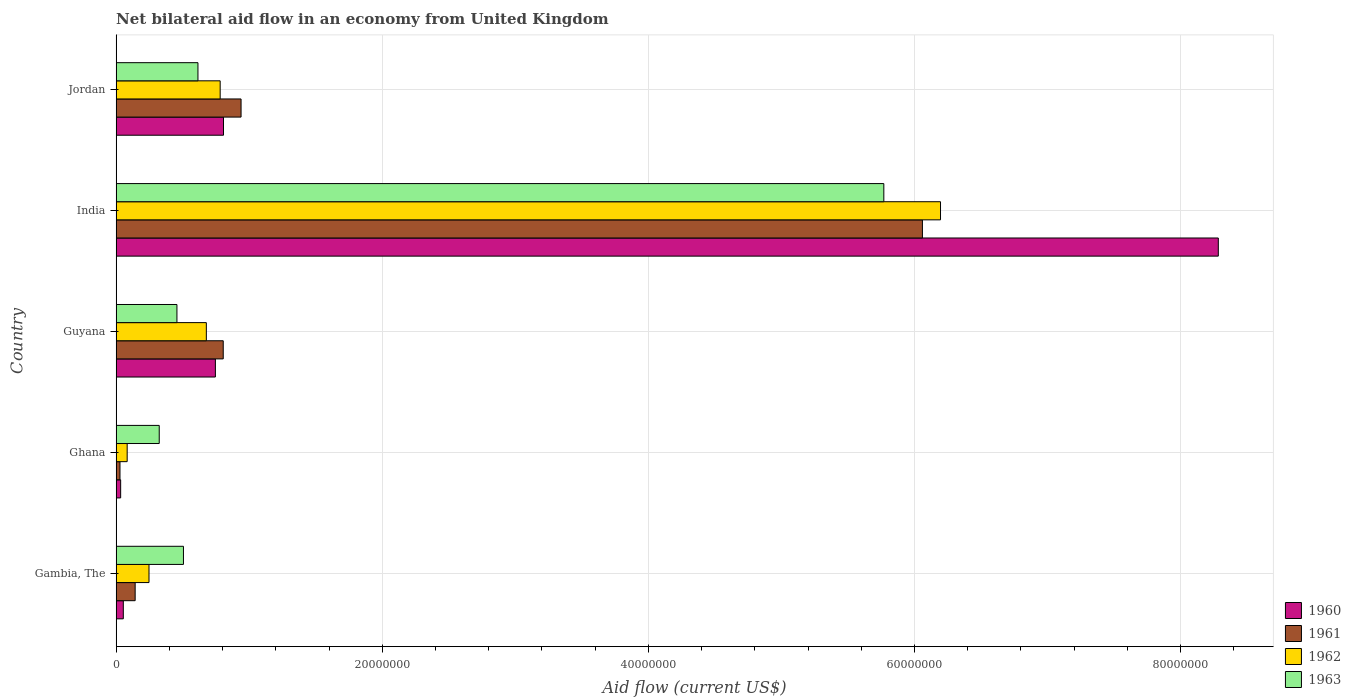How many different coloured bars are there?
Ensure brevity in your answer.  4. Are the number of bars per tick equal to the number of legend labels?
Give a very brief answer. Yes. Are the number of bars on each tick of the Y-axis equal?
Your response must be concise. Yes. How many bars are there on the 3rd tick from the top?
Give a very brief answer. 4. What is the label of the 1st group of bars from the top?
Your answer should be compact. Jordan. In how many cases, is the number of bars for a given country not equal to the number of legend labels?
Provide a succinct answer. 0. What is the net bilateral aid flow in 1963 in India?
Provide a short and direct response. 5.77e+07. Across all countries, what is the maximum net bilateral aid flow in 1962?
Ensure brevity in your answer.  6.20e+07. Across all countries, what is the minimum net bilateral aid flow in 1961?
Provide a succinct answer. 2.90e+05. In which country was the net bilateral aid flow in 1963 maximum?
Ensure brevity in your answer.  India. What is the total net bilateral aid flow in 1960 in the graph?
Offer a very short reply. 9.92e+07. What is the difference between the net bilateral aid flow in 1962 in Ghana and that in Guyana?
Give a very brief answer. -5.95e+06. What is the difference between the net bilateral aid flow in 1962 in Jordan and the net bilateral aid flow in 1960 in Gambia, The?
Give a very brief answer. 7.28e+06. What is the average net bilateral aid flow in 1961 per country?
Keep it short and to the point. 1.60e+07. What is the difference between the net bilateral aid flow in 1960 and net bilateral aid flow in 1961 in Guyana?
Offer a terse response. -5.90e+05. In how many countries, is the net bilateral aid flow in 1963 greater than 68000000 US$?
Your answer should be very brief. 0. What is the ratio of the net bilateral aid flow in 1961 in Gambia, The to that in Ghana?
Give a very brief answer. 4.93. Is the net bilateral aid flow in 1963 in Gambia, The less than that in Jordan?
Ensure brevity in your answer.  Yes. Is the difference between the net bilateral aid flow in 1960 in Ghana and Guyana greater than the difference between the net bilateral aid flow in 1961 in Ghana and Guyana?
Give a very brief answer. Yes. What is the difference between the highest and the second highest net bilateral aid flow in 1961?
Your answer should be very brief. 5.12e+07. What is the difference between the highest and the lowest net bilateral aid flow in 1962?
Ensure brevity in your answer.  6.11e+07. Is the sum of the net bilateral aid flow in 1961 in Gambia, The and Guyana greater than the maximum net bilateral aid flow in 1963 across all countries?
Ensure brevity in your answer.  No. Is it the case that in every country, the sum of the net bilateral aid flow in 1960 and net bilateral aid flow in 1962 is greater than the sum of net bilateral aid flow in 1961 and net bilateral aid flow in 1963?
Give a very brief answer. No. What does the 3rd bar from the top in Guyana represents?
Your answer should be compact. 1961. What does the 2nd bar from the bottom in Guyana represents?
Your response must be concise. 1961. Is it the case that in every country, the sum of the net bilateral aid flow in 1960 and net bilateral aid flow in 1963 is greater than the net bilateral aid flow in 1961?
Your answer should be very brief. Yes. How many countries are there in the graph?
Ensure brevity in your answer.  5. Does the graph contain any zero values?
Your answer should be compact. No. What is the title of the graph?
Your response must be concise. Net bilateral aid flow in an economy from United Kingdom. What is the label or title of the X-axis?
Keep it short and to the point. Aid flow (current US$). What is the label or title of the Y-axis?
Ensure brevity in your answer.  Country. What is the Aid flow (current US$) in 1960 in Gambia, The?
Make the answer very short. 5.40e+05. What is the Aid flow (current US$) in 1961 in Gambia, The?
Offer a very short reply. 1.43e+06. What is the Aid flow (current US$) of 1962 in Gambia, The?
Ensure brevity in your answer.  2.47e+06. What is the Aid flow (current US$) in 1963 in Gambia, The?
Ensure brevity in your answer.  5.06e+06. What is the Aid flow (current US$) of 1960 in Ghana?
Your answer should be very brief. 3.40e+05. What is the Aid flow (current US$) in 1962 in Ghana?
Offer a terse response. 8.30e+05. What is the Aid flow (current US$) of 1963 in Ghana?
Offer a terse response. 3.24e+06. What is the Aid flow (current US$) of 1960 in Guyana?
Provide a short and direct response. 7.46e+06. What is the Aid flow (current US$) in 1961 in Guyana?
Provide a short and direct response. 8.05e+06. What is the Aid flow (current US$) in 1962 in Guyana?
Your response must be concise. 6.78e+06. What is the Aid flow (current US$) of 1963 in Guyana?
Your response must be concise. 4.57e+06. What is the Aid flow (current US$) of 1960 in India?
Your response must be concise. 8.28e+07. What is the Aid flow (current US$) of 1961 in India?
Give a very brief answer. 6.06e+07. What is the Aid flow (current US$) of 1962 in India?
Keep it short and to the point. 6.20e+07. What is the Aid flow (current US$) of 1963 in India?
Give a very brief answer. 5.77e+07. What is the Aid flow (current US$) in 1960 in Jordan?
Your answer should be compact. 8.07e+06. What is the Aid flow (current US$) of 1961 in Jordan?
Your answer should be compact. 9.39e+06. What is the Aid flow (current US$) in 1962 in Jordan?
Your answer should be compact. 7.82e+06. What is the Aid flow (current US$) of 1963 in Jordan?
Offer a very short reply. 6.15e+06. Across all countries, what is the maximum Aid flow (current US$) in 1960?
Give a very brief answer. 8.28e+07. Across all countries, what is the maximum Aid flow (current US$) of 1961?
Keep it short and to the point. 6.06e+07. Across all countries, what is the maximum Aid flow (current US$) in 1962?
Give a very brief answer. 6.20e+07. Across all countries, what is the maximum Aid flow (current US$) of 1963?
Make the answer very short. 5.77e+07. Across all countries, what is the minimum Aid flow (current US$) in 1960?
Give a very brief answer. 3.40e+05. Across all countries, what is the minimum Aid flow (current US$) of 1962?
Offer a terse response. 8.30e+05. Across all countries, what is the minimum Aid flow (current US$) in 1963?
Offer a terse response. 3.24e+06. What is the total Aid flow (current US$) in 1960 in the graph?
Offer a very short reply. 9.92e+07. What is the total Aid flow (current US$) of 1961 in the graph?
Provide a succinct answer. 7.98e+07. What is the total Aid flow (current US$) of 1962 in the graph?
Give a very brief answer. 7.99e+07. What is the total Aid flow (current US$) in 1963 in the graph?
Provide a succinct answer. 7.67e+07. What is the difference between the Aid flow (current US$) in 1960 in Gambia, The and that in Ghana?
Give a very brief answer. 2.00e+05. What is the difference between the Aid flow (current US$) in 1961 in Gambia, The and that in Ghana?
Offer a terse response. 1.14e+06. What is the difference between the Aid flow (current US$) of 1962 in Gambia, The and that in Ghana?
Offer a very short reply. 1.64e+06. What is the difference between the Aid flow (current US$) in 1963 in Gambia, The and that in Ghana?
Keep it short and to the point. 1.82e+06. What is the difference between the Aid flow (current US$) in 1960 in Gambia, The and that in Guyana?
Provide a short and direct response. -6.92e+06. What is the difference between the Aid flow (current US$) of 1961 in Gambia, The and that in Guyana?
Provide a succinct answer. -6.62e+06. What is the difference between the Aid flow (current US$) in 1962 in Gambia, The and that in Guyana?
Keep it short and to the point. -4.31e+06. What is the difference between the Aid flow (current US$) in 1963 in Gambia, The and that in Guyana?
Provide a succinct answer. 4.90e+05. What is the difference between the Aid flow (current US$) in 1960 in Gambia, The and that in India?
Give a very brief answer. -8.23e+07. What is the difference between the Aid flow (current US$) in 1961 in Gambia, The and that in India?
Make the answer very short. -5.92e+07. What is the difference between the Aid flow (current US$) in 1962 in Gambia, The and that in India?
Your answer should be compact. -5.95e+07. What is the difference between the Aid flow (current US$) of 1963 in Gambia, The and that in India?
Your answer should be compact. -5.26e+07. What is the difference between the Aid flow (current US$) of 1960 in Gambia, The and that in Jordan?
Ensure brevity in your answer.  -7.53e+06. What is the difference between the Aid flow (current US$) in 1961 in Gambia, The and that in Jordan?
Provide a succinct answer. -7.96e+06. What is the difference between the Aid flow (current US$) of 1962 in Gambia, The and that in Jordan?
Keep it short and to the point. -5.35e+06. What is the difference between the Aid flow (current US$) of 1963 in Gambia, The and that in Jordan?
Provide a succinct answer. -1.09e+06. What is the difference between the Aid flow (current US$) of 1960 in Ghana and that in Guyana?
Provide a succinct answer. -7.12e+06. What is the difference between the Aid flow (current US$) of 1961 in Ghana and that in Guyana?
Provide a succinct answer. -7.76e+06. What is the difference between the Aid flow (current US$) in 1962 in Ghana and that in Guyana?
Offer a terse response. -5.95e+06. What is the difference between the Aid flow (current US$) in 1963 in Ghana and that in Guyana?
Your answer should be very brief. -1.33e+06. What is the difference between the Aid flow (current US$) of 1960 in Ghana and that in India?
Ensure brevity in your answer.  -8.25e+07. What is the difference between the Aid flow (current US$) in 1961 in Ghana and that in India?
Provide a short and direct response. -6.03e+07. What is the difference between the Aid flow (current US$) in 1962 in Ghana and that in India?
Your response must be concise. -6.11e+07. What is the difference between the Aid flow (current US$) in 1963 in Ghana and that in India?
Your answer should be compact. -5.45e+07. What is the difference between the Aid flow (current US$) of 1960 in Ghana and that in Jordan?
Your answer should be very brief. -7.73e+06. What is the difference between the Aid flow (current US$) in 1961 in Ghana and that in Jordan?
Give a very brief answer. -9.10e+06. What is the difference between the Aid flow (current US$) of 1962 in Ghana and that in Jordan?
Keep it short and to the point. -6.99e+06. What is the difference between the Aid flow (current US$) of 1963 in Ghana and that in Jordan?
Ensure brevity in your answer.  -2.91e+06. What is the difference between the Aid flow (current US$) in 1960 in Guyana and that in India?
Offer a very short reply. -7.54e+07. What is the difference between the Aid flow (current US$) in 1961 in Guyana and that in India?
Ensure brevity in your answer.  -5.26e+07. What is the difference between the Aid flow (current US$) in 1962 in Guyana and that in India?
Make the answer very short. -5.52e+07. What is the difference between the Aid flow (current US$) in 1963 in Guyana and that in India?
Give a very brief answer. -5.31e+07. What is the difference between the Aid flow (current US$) of 1960 in Guyana and that in Jordan?
Your answer should be compact. -6.10e+05. What is the difference between the Aid flow (current US$) of 1961 in Guyana and that in Jordan?
Your answer should be compact. -1.34e+06. What is the difference between the Aid flow (current US$) of 1962 in Guyana and that in Jordan?
Provide a short and direct response. -1.04e+06. What is the difference between the Aid flow (current US$) in 1963 in Guyana and that in Jordan?
Your answer should be very brief. -1.58e+06. What is the difference between the Aid flow (current US$) in 1960 in India and that in Jordan?
Give a very brief answer. 7.48e+07. What is the difference between the Aid flow (current US$) of 1961 in India and that in Jordan?
Give a very brief answer. 5.12e+07. What is the difference between the Aid flow (current US$) in 1962 in India and that in Jordan?
Give a very brief answer. 5.41e+07. What is the difference between the Aid flow (current US$) in 1963 in India and that in Jordan?
Your answer should be very brief. 5.16e+07. What is the difference between the Aid flow (current US$) of 1960 in Gambia, The and the Aid flow (current US$) of 1961 in Ghana?
Offer a terse response. 2.50e+05. What is the difference between the Aid flow (current US$) in 1960 in Gambia, The and the Aid flow (current US$) in 1963 in Ghana?
Provide a short and direct response. -2.70e+06. What is the difference between the Aid flow (current US$) in 1961 in Gambia, The and the Aid flow (current US$) in 1962 in Ghana?
Keep it short and to the point. 6.00e+05. What is the difference between the Aid flow (current US$) in 1961 in Gambia, The and the Aid flow (current US$) in 1963 in Ghana?
Your answer should be very brief. -1.81e+06. What is the difference between the Aid flow (current US$) of 1962 in Gambia, The and the Aid flow (current US$) of 1963 in Ghana?
Make the answer very short. -7.70e+05. What is the difference between the Aid flow (current US$) of 1960 in Gambia, The and the Aid flow (current US$) of 1961 in Guyana?
Provide a short and direct response. -7.51e+06. What is the difference between the Aid flow (current US$) of 1960 in Gambia, The and the Aid flow (current US$) of 1962 in Guyana?
Your answer should be very brief. -6.24e+06. What is the difference between the Aid flow (current US$) in 1960 in Gambia, The and the Aid flow (current US$) in 1963 in Guyana?
Give a very brief answer. -4.03e+06. What is the difference between the Aid flow (current US$) in 1961 in Gambia, The and the Aid flow (current US$) in 1962 in Guyana?
Give a very brief answer. -5.35e+06. What is the difference between the Aid flow (current US$) of 1961 in Gambia, The and the Aid flow (current US$) of 1963 in Guyana?
Give a very brief answer. -3.14e+06. What is the difference between the Aid flow (current US$) in 1962 in Gambia, The and the Aid flow (current US$) in 1963 in Guyana?
Your answer should be compact. -2.10e+06. What is the difference between the Aid flow (current US$) in 1960 in Gambia, The and the Aid flow (current US$) in 1961 in India?
Make the answer very short. -6.01e+07. What is the difference between the Aid flow (current US$) in 1960 in Gambia, The and the Aid flow (current US$) in 1962 in India?
Your answer should be very brief. -6.14e+07. What is the difference between the Aid flow (current US$) in 1960 in Gambia, The and the Aid flow (current US$) in 1963 in India?
Your response must be concise. -5.72e+07. What is the difference between the Aid flow (current US$) in 1961 in Gambia, The and the Aid flow (current US$) in 1962 in India?
Offer a terse response. -6.05e+07. What is the difference between the Aid flow (current US$) of 1961 in Gambia, The and the Aid flow (current US$) of 1963 in India?
Provide a succinct answer. -5.63e+07. What is the difference between the Aid flow (current US$) in 1962 in Gambia, The and the Aid flow (current US$) in 1963 in India?
Ensure brevity in your answer.  -5.52e+07. What is the difference between the Aid flow (current US$) in 1960 in Gambia, The and the Aid flow (current US$) in 1961 in Jordan?
Ensure brevity in your answer.  -8.85e+06. What is the difference between the Aid flow (current US$) of 1960 in Gambia, The and the Aid flow (current US$) of 1962 in Jordan?
Make the answer very short. -7.28e+06. What is the difference between the Aid flow (current US$) in 1960 in Gambia, The and the Aid flow (current US$) in 1963 in Jordan?
Offer a very short reply. -5.61e+06. What is the difference between the Aid flow (current US$) of 1961 in Gambia, The and the Aid flow (current US$) of 1962 in Jordan?
Offer a terse response. -6.39e+06. What is the difference between the Aid flow (current US$) of 1961 in Gambia, The and the Aid flow (current US$) of 1963 in Jordan?
Make the answer very short. -4.72e+06. What is the difference between the Aid flow (current US$) in 1962 in Gambia, The and the Aid flow (current US$) in 1963 in Jordan?
Your response must be concise. -3.68e+06. What is the difference between the Aid flow (current US$) in 1960 in Ghana and the Aid flow (current US$) in 1961 in Guyana?
Offer a very short reply. -7.71e+06. What is the difference between the Aid flow (current US$) in 1960 in Ghana and the Aid flow (current US$) in 1962 in Guyana?
Make the answer very short. -6.44e+06. What is the difference between the Aid flow (current US$) in 1960 in Ghana and the Aid flow (current US$) in 1963 in Guyana?
Ensure brevity in your answer.  -4.23e+06. What is the difference between the Aid flow (current US$) in 1961 in Ghana and the Aid flow (current US$) in 1962 in Guyana?
Provide a succinct answer. -6.49e+06. What is the difference between the Aid flow (current US$) in 1961 in Ghana and the Aid flow (current US$) in 1963 in Guyana?
Give a very brief answer. -4.28e+06. What is the difference between the Aid flow (current US$) in 1962 in Ghana and the Aid flow (current US$) in 1963 in Guyana?
Keep it short and to the point. -3.74e+06. What is the difference between the Aid flow (current US$) in 1960 in Ghana and the Aid flow (current US$) in 1961 in India?
Your answer should be very brief. -6.03e+07. What is the difference between the Aid flow (current US$) in 1960 in Ghana and the Aid flow (current US$) in 1962 in India?
Make the answer very short. -6.16e+07. What is the difference between the Aid flow (current US$) of 1960 in Ghana and the Aid flow (current US$) of 1963 in India?
Make the answer very short. -5.74e+07. What is the difference between the Aid flow (current US$) of 1961 in Ghana and the Aid flow (current US$) of 1962 in India?
Your response must be concise. -6.17e+07. What is the difference between the Aid flow (current US$) of 1961 in Ghana and the Aid flow (current US$) of 1963 in India?
Your answer should be compact. -5.74e+07. What is the difference between the Aid flow (current US$) of 1962 in Ghana and the Aid flow (current US$) of 1963 in India?
Your answer should be compact. -5.69e+07. What is the difference between the Aid flow (current US$) in 1960 in Ghana and the Aid flow (current US$) in 1961 in Jordan?
Provide a short and direct response. -9.05e+06. What is the difference between the Aid flow (current US$) in 1960 in Ghana and the Aid flow (current US$) in 1962 in Jordan?
Offer a very short reply. -7.48e+06. What is the difference between the Aid flow (current US$) in 1960 in Ghana and the Aid flow (current US$) in 1963 in Jordan?
Provide a succinct answer. -5.81e+06. What is the difference between the Aid flow (current US$) of 1961 in Ghana and the Aid flow (current US$) of 1962 in Jordan?
Give a very brief answer. -7.53e+06. What is the difference between the Aid flow (current US$) in 1961 in Ghana and the Aid flow (current US$) in 1963 in Jordan?
Offer a terse response. -5.86e+06. What is the difference between the Aid flow (current US$) of 1962 in Ghana and the Aid flow (current US$) of 1963 in Jordan?
Your answer should be very brief. -5.32e+06. What is the difference between the Aid flow (current US$) of 1960 in Guyana and the Aid flow (current US$) of 1961 in India?
Your response must be concise. -5.31e+07. What is the difference between the Aid flow (current US$) of 1960 in Guyana and the Aid flow (current US$) of 1962 in India?
Provide a succinct answer. -5.45e+07. What is the difference between the Aid flow (current US$) in 1960 in Guyana and the Aid flow (current US$) in 1963 in India?
Provide a succinct answer. -5.02e+07. What is the difference between the Aid flow (current US$) of 1961 in Guyana and the Aid flow (current US$) of 1962 in India?
Give a very brief answer. -5.39e+07. What is the difference between the Aid flow (current US$) in 1961 in Guyana and the Aid flow (current US$) in 1963 in India?
Give a very brief answer. -4.96e+07. What is the difference between the Aid flow (current US$) in 1962 in Guyana and the Aid flow (current US$) in 1963 in India?
Provide a succinct answer. -5.09e+07. What is the difference between the Aid flow (current US$) in 1960 in Guyana and the Aid flow (current US$) in 1961 in Jordan?
Offer a very short reply. -1.93e+06. What is the difference between the Aid flow (current US$) of 1960 in Guyana and the Aid flow (current US$) of 1962 in Jordan?
Provide a short and direct response. -3.60e+05. What is the difference between the Aid flow (current US$) of 1960 in Guyana and the Aid flow (current US$) of 1963 in Jordan?
Offer a terse response. 1.31e+06. What is the difference between the Aid flow (current US$) in 1961 in Guyana and the Aid flow (current US$) in 1963 in Jordan?
Ensure brevity in your answer.  1.90e+06. What is the difference between the Aid flow (current US$) of 1962 in Guyana and the Aid flow (current US$) of 1963 in Jordan?
Provide a succinct answer. 6.30e+05. What is the difference between the Aid flow (current US$) in 1960 in India and the Aid flow (current US$) in 1961 in Jordan?
Offer a terse response. 7.34e+07. What is the difference between the Aid flow (current US$) of 1960 in India and the Aid flow (current US$) of 1962 in Jordan?
Offer a very short reply. 7.50e+07. What is the difference between the Aid flow (current US$) in 1960 in India and the Aid flow (current US$) in 1963 in Jordan?
Offer a very short reply. 7.67e+07. What is the difference between the Aid flow (current US$) of 1961 in India and the Aid flow (current US$) of 1962 in Jordan?
Your response must be concise. 5.28e+07. What is the difference between the Aid flow (current US$) in 1961 in India and the Aid flow (current US$) in 1963 in Jordan?
Offer a very short reply. 5.44e+07. What is the difference between the Aid flow (current US$) of 1962 in India and the Aid flow (current US$) of 1963 in Jordan?
Provide a succinct answer. 5.58e+07. What is the average Aid flow (current US$) in 1960 per country?
Offer a terse response. 1.98e+07. What is the average Aid flow (current US$) of 1961 per country?
Your answer should be compact. 1.60e+07. What is the average Aid flow (current US$) of 1962 per country?
Your answer should be very brief. 1.60e+07. What is the average Aid flow (current US$) of 1963 per country?
Give a very brief answer. 1.53e+07. What is the difference between the Aid flow (current US$) of 1960 and Aid flow (current US$) of 1961 in Gambia, The?
Give a very brief answer. -8.90e+05. What is the difference between the Aid flow (current US$) of 1960 and Aid flow (current US$) of 1962 in Gambia, The?
Ensure brevity in your answer.  -1.93e+06. What is the difference between the Aid flow (current US$) of 1960 and Aid flow (current US$) of 1963 in Gambia, The?
Offer a terse response. -4.52e+06. What is the difference between the Aid flow (current US$) of 1961 and Aid flow (current US$) of 1962 in Gambia, The?
Your answer should be compact. -1.04e+06. What is the difference between the Aid flow (current US$) in 1961 and Aid flow (current US$) in 1963 in Gambia, The?
Offer a terse response. -3.63e+06. What is the difference between the Aid flow (current US$) in 1962 and Aid flow (current US$) in 1963 in Gambia, The?
Provide a short and direct response. -2.59e+06. What is the difference between the Aid flow (current US$) in 1960 and Aid flow (current US$) in 1962 in Ghana?
Make the answer very short. -4.90e+05. What is the difference between the Aid flow (current US$) in 1960 and Aid flow (current US$) in 1963 in Ghana?
Make the answer very short. -2.90e+06. What is the difference between the Aid flow (current US$) of 1961 and Aid flow (current US$) of 1962 in Ghana?
Give a very brief answer. -5.40e+05. What is the difference between the Aid flow (current US$) in 1961 and Aid flow (current US$) in 1963 in Ghana?
Give a very brief answer. -2.95e+06. What is the difference between the Aid flow (current US$) of 1962 and Aid flow (current US$) of 1963 in Ghana?
Your answer should be compact. -2.41e+06. What is the difference between the Aid flow (current US$) in 1960 and Aid flow (current US$) in 1961 in Guyana?
Offer a terse response. -5.90e+05. What is the difference between the Aid flow (current US$) in 1960 and Aid flow (current US$) in 1962 in Guyana?
Ensure brevity in your answer.  6.80e+05. What is the difference between the Aid flow (current US$) of 1960 and Aid flow (current US$) of 1963 in Guyana?
Keep it short and to the point. 2.89e+06. What is the difference between the Aid flow (current US$) in 1961 and Aid flow (current US$) in 1962 in Guyana?
Provide a short and direct response. 1.27e+06. What is the difference between the Aid flow (current US$) in 1961 and Aid flow (current US$) in 1963 in Guyana?
Give a very brief answer. 3.48e+06. What is the difference between the Aid flow (current US$) of 1962 and Aid flow (current US$) of 1963 in Guyana?
Your answer should be very brief. 2.21e+06. What is the difference between the Aid flow (current US$) in 1960 and Aid flow (current US$) in 1961 in India?
Your answer should be very brief. 2.22e+07. What is the difference between the Aid flow (current US$) in 1960 and Aid flow (current US$) in 1962 in India?
Your answer should be compact. 2.09e+07. What is the difference between the Aid flow (current US$) in 1960 and Aid flow (current US$) in 1963 in India?
Provide a succinct answer. 2.51e+07. What is the difference between the Aid flow (current US$) of 1961 and Aid flow (current US$) of 1962 in India?
Ensure brevity in your answer.  -1.36e+06. What is the difference between the Aid flow (current US$) of 1961 and Aid flow (current US$) of 1963 in India?
Ensure brevity in your answer.  2.90e+06. What is the difference between the Aid flow (current US$) of 1962 and Aid flow (current US$) of 1963 in India?
Your response must be concise. 4.26e+06. What is the difference between the Aid flow (current US$) of 1960 and Aid flow (current US$) of 1961 in Jordan?
Make the answer very short. -1.32e+06. What is the difference between the Aid flow (current US$) in 1960 and Aid flow (current US$) in 1962 in Jordan?
Your response must be concise. 2.50e+05. What is the difference between the Aid flow (current US$) of 1960 and Aid flow (current US$) of 1963 in Jordan?
Offer a terse response. 1.92e+06. What is the difference between the Aid flow (current US$) in 1961 and Aid flow (current US$) in 1962 in Jordan?
Make the answer very short. 1.57e+06. What is the difference between the Aid flow (current US$) of 1961 and Aid flow (current US$) of 1963 in Jordan?
Your answer should be compact. 3.24e+06. What is the difference between the Aid flow (current US$) in 1962 and Aid flow (current US$) in 1963 in Jordan?
Your answer should be very brief. 1.67e+06. What is the ratio of the Aid flow (current US$) of 1960 in Gambia, The to that in Ghana?
Provide a succinct answer. 1.59. What is the ratio of the Aid flow (current US$) in 1961 in Gambia, The to that in Ghana?
Ensure brevity in your answer.  4.93. What is the ratio of the Aid flow (current US$) in 1962 in Gambia, The to that in Ghana?
Offer a terse response. 2.98. What is the ratio of the Aid flow (current US$) in 1963 in Gambia, The to that in Ghana?
Your answer should be compact. 1.56. What is the ratio of the Aid flow (current US$) in 1960 in Gambia, The to that in Guyana?
Your answer should be compact. 0.07. What is the ratio of the Aid flow (current US$) in 1961 in Gambia, The to that in Guyana?
Offer a very short reply. 0.18. What is the ratio of the Aid flow (current US$) of 1962 in Gambia, The to that in Guyana?
Make the answer very short. 0.36. What is the ratio of the Aid flow (current US$) of 1963 in Gambia, The to that in Guyana?
Give a very brief answer. 1.11. What is the ratio of the Aid flow (current US$) in 1960 in Gambia, The to that in India?
Your answer should be compact. 0.01. What is the ratio of the Aid flow (current US$) in 1961 in Gambia, The to that in India?
Keep it short and to the point. 0.02. What is the ratio of the Aid flow (current US$) in 1962 in Gambia, The to that in India?
Your answer should be very brief. 0.04. What is the ratio of the Aid flow (current US$) in 1963 in Gambia, The to that in India?
Your response must be concise. 0.09. What is the ratio of the Aid flow (current US$) of 1960 in Gambia, The to that in Jordan?
Keep it short and to the point. 0.07. What is the ratio of the Aid flow (current US$) in 1961 in Gambia, The to that in Jordan?
Provide a short and direct response. 0.15. What is the ratio of the Aid flow (current US$) in 1962 in Gambia, The to that in Jordan?
Ensure brevity in your answer.  0.32. What is the ratio of the Aid flow (current US$) in 1963 in Gambia, The to that in Jordan?
Keep it short and to the point. 0.82. What is the ratio of the Aid flow (current US$) of 1960 in Ghana to that in Guyana?
Give a very brief answer. 0.05. What is the ratio of the Aid flow (current US$) of 1961 in Ghana to that in Guyana?
Ensure brevity in your answer.  0.04. What is the ratio of the Aid flow (current US$) in 1962 in Ghana to that in Guyana?
Provide a succinct answer. 0.12. What is the ratio of the Aid flow (current US$) of 1963 in Ghana to that in Guyana?
Your answer should be very brief. 0.71. What is the ratio of the Aid flow (current US$) in 1960 in Ghana to that in India?
Ensure brevity in your answer.  0. What is the ratio of the Aid flow (current US$) of 1961 in Ghana to that in India?
Provide a short and direct response. 0. What is the ratio of the Aid flow (current US$) of 1962 in Ghana to that in India?
Give a very brief answer. 0.01. What is the ratio of the Aid flow (current US$) of 1963 in Ghana to that in India?
Make the answer very short. 0.06. What is the ratio of the Aid flow (current US$) in 1960 in Ghana to that in Jordan?
Your answer should be compact. 0.04. What is the ratio of the Aid flow (current US$) in 1961 in Ghana to that in Jordan?
Keep it short and to the point. 0.03. What is the ratio of the Aid flow (current US$) in 1962 in Ghana to that in Jordan?
Your response must be concise. 0.11. What is the ratio of the Aid flow (current US$) in 1963 in Ghana to that in Jordan?
Ensure brevity in your answer.  0.53. What is the ratio of the Aid flow (current US$) in 1960 in Guyana to that in India?
Give a very brief answer. 0.09. What is the ratio of the Aid flow (current US$) in 1961 in Guyana to that in India?
Offer a very short reply. 0.13. What is the ratio of the Aid flow (current US$) of 1962 in Guyana to that in India?
Offer a terse response. 0.11. What is the ratio of the Aid flow (current US$) in 1963 in Guyana to that in India?
Provide a succinct answer. 0.08. What is the ratio of the Aid flow (current US$) in 1960 in Guyana to that in Jordan?
Your answer should be very brief. 0.92. What is the ratio of the Aid flow (current US$) in 1961 in Guyana to that in Jordan?
Keep it short and to the point. 0.86. What is the ratio of the Aid flow (current US$) of 1962 in Guyana to that in Jordan?
Offer a terse response. 0.87. What is the ratio of the Aid flow (current US$) in 1963 in Guyana to that in Jordan?
Give a very brief answer. 0.74. What is the ratio of the Aid flow (current US$) in 1960 in India to that in Jordan?
Make the answer very short. 10.27. What is the ratio of the Aid flow (current US$) of 1961 in India to that in Jordan?
Provide a succinct answer. 6.45. What is the ratio of the Aid flow (current US$) of 1962 in India to that in Jordan?
Make the answer very short. 7.92. What is the ratio of the Aid flow (current US$) in 1963 in India to that in Jordan?
Ensure brevity in your answer.  9.38. What is the difference between the highest and the second highest Aid flow (current US$) of 1960?
Give a very brief answer. 7.48e+07. What is the difference between the highest and the second highest Aid flow (current US$) in 1961?
Your answer should be very brief. 5.12e+07. What is the difference between the highest and the second highest Aid flow (current US$) in 1962?
Your answer should be very brief. 5.41e+07. What is the difference between the highest and the second highest Aid flow (current US$) of 1963?
Provide a succinct answer. 5.16e+07. What is the difference between the highest and the lowest Aid flow (current US$) of 1960?
Your answer should be very brief. 8.25e+07. What is the difference between the highest and the lowest Aid flow (current US$) of 1961?
Keep it short and to the point. 6.03e+07. What is the difference between the highest and the lowest Aid flow (current US$) of 1962?
Keep it short and to the point. 6.11e+07. What is the difference between the highest and the lowest Aid flow (current US$) in 1963?
Your answer should be very brief. 5.45e+07. 